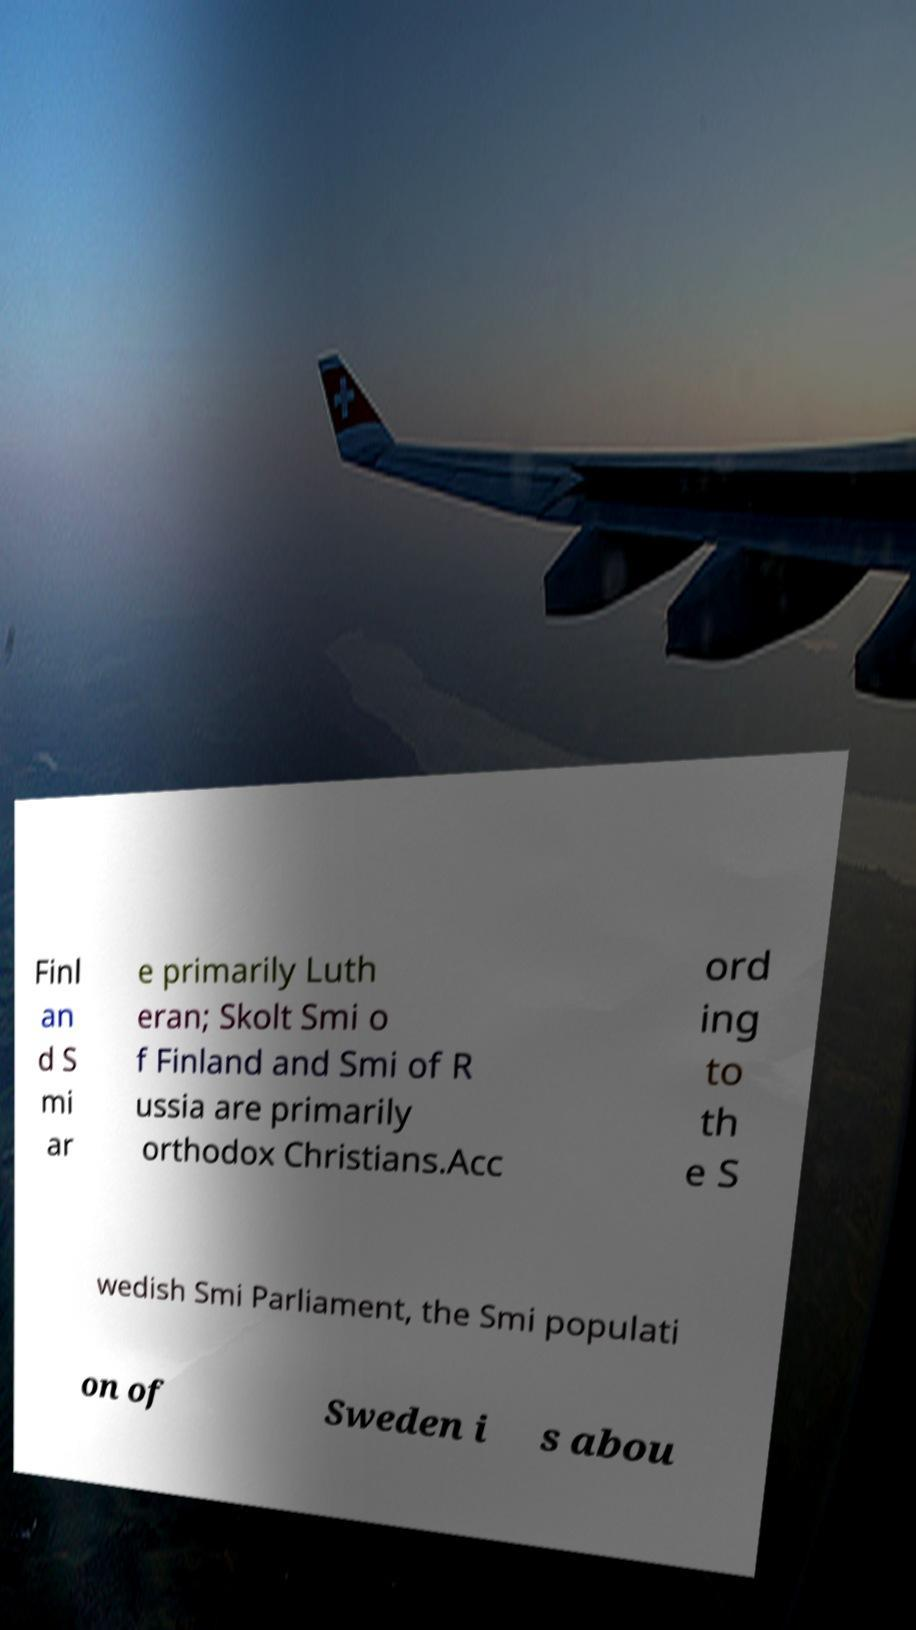Please identify and transcribe the text found in this image. Finl an d S mi ar e primarily Luth eran; Skolt Smi o f Finland and Smi of R ussia are primarily orthodox Christians.Acc ord ing to th e S wedish Smi Parliament, the Smi populati on of Sweden i s abou 